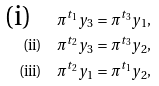Convert formula to latex. <formula><loc_0><loc_0><loc_500><loc_500>\text {(i)} \quad \pi ^ { t _ { 1 } } y _ { 3 } & = \pi ^ { t _ { 3 } } y _ { 1 } , \\ \text {(ii)} \quad \pi ^ { t _ { 2 } } y _ { 3 } & = \pi ^ { t _ { 3 } } y _ { 2 } , \\ \text {(iii)} \quad \pi ^ { t _ { 2 } } y _ { 1 } & = \pi ^ { t _ { 1 } } y _ { 2 } ,</formula> 